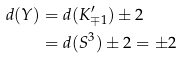Convert formula to latex. <formula><loc_0><loc_0><loc_500><loc_500>d ( Y ) & = d ( K ^ { \prime } _ { \mp 1 } ) \pm 2 \\ & = d ( S ^ { 3 } ) \pm 2 = \pm 2</formula> 